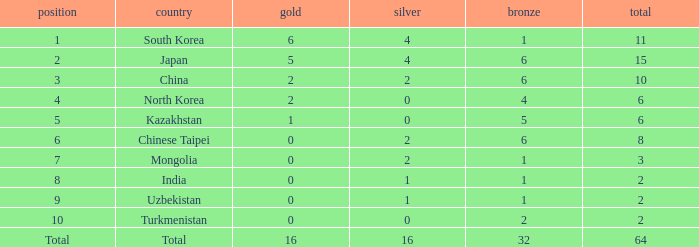What rank is Turkmenistan, who had 0 silver's and Less than 2 golds? 10.0. 